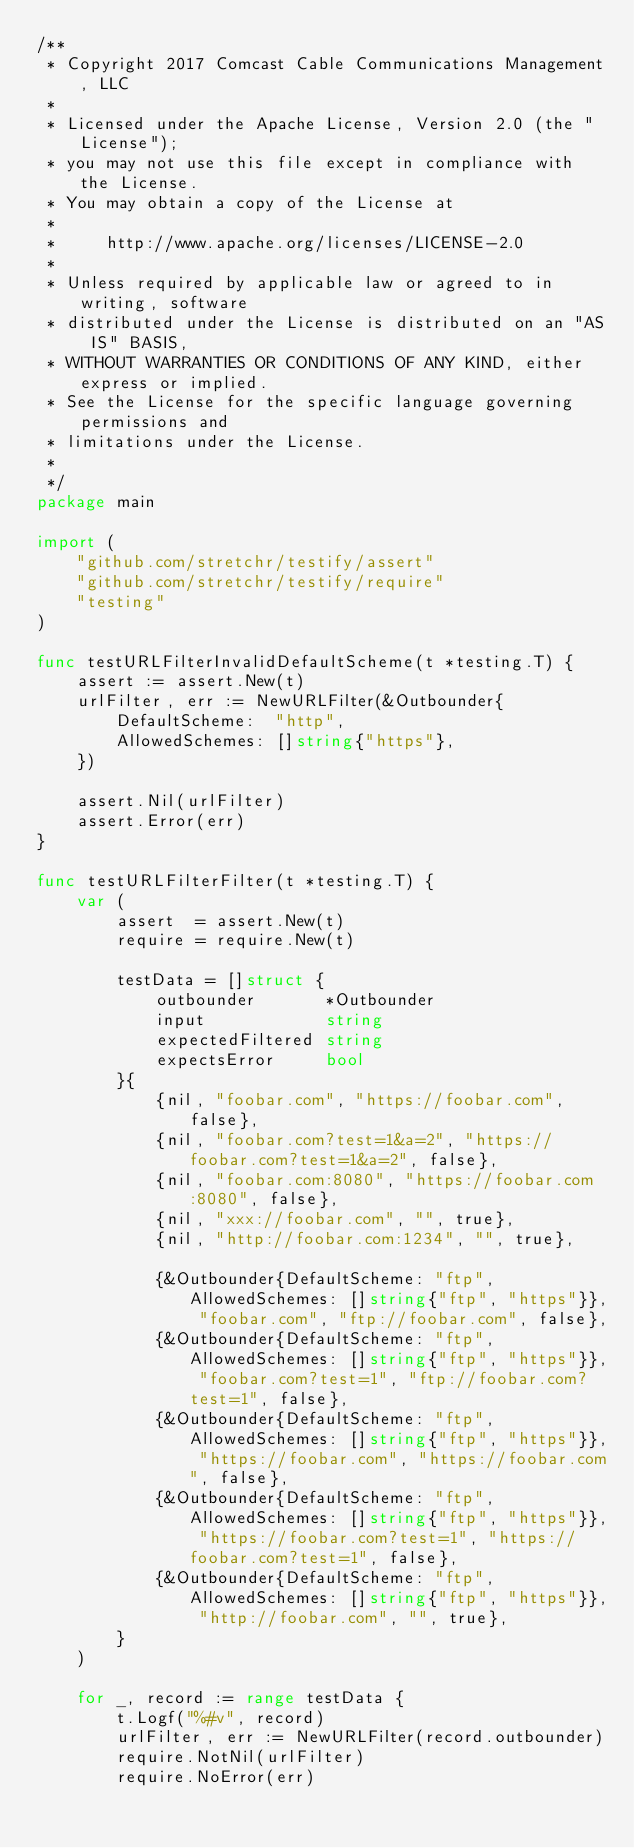<code> <loc_0><loc_0><loc_500><loc_500><_Go_>/**
 * Copyright 2017 Comcast Cable Communications Management, LLC
 *
 * Licensed under the Apache License, Version 2.0 (the "License");
 * you may not use this file except in compliance with the License.
 * You may obtain a copy of the License at
 *
 *     http://www.apache.org/licenses/LICENSE-2.0
 *
 * Unless required by applicable law or agreed to in writing, software
 * distributed under the License is distributed on an "AS IS" BASIS,
 * WITHOUT WARRANTIES OR CONDITIONS OF ANY KIND, either express or implied.
 * See the License for the specific language governing permissions and
 * limitations under the License.
 *
 */
package main

import (
	"github.com/stretchr/testify/assert"
	"github.com/stretchr/testify/require"
	"testing"
)

func testURLFilterInvalidDefaultScheme(t *testing.T) {
	assert := assert.New(t)
	urlFilter, err := NewURLFilter(&Outbounder{
		DefaultScheme:  "http",
		AllowedSchemes: []string{"https"},
	})

	assert.Nil(urlFilter)
	assert.Error(err)
}

func testURLFilterFilter(t *testing.T) {
	var (
		assert  = assert.New(t)
		require = require.New(t)

		testData = []struct {
			outbounder       *Outbounder
			input            string
			expectedFiltered string
			expectsError     bool
		}{
			{nil, "foobar.com", "https://foobar.com", false},
			{nil, "foobar.com?test=1&a=2", "https://foobar.com?test=1&a=2", false},
			{nil, "foobar.com:8080", "https://foobar.com:8080", false},
			{nil, "xxx://foobar.com", "", true},
			{nil, "http://foobar.com:1234", "", true},

			{&Outbounder{DefaultScheme: "ftp", AllowedSchemes: []string{"ftp", "https"}}, "foobar.com", "ftp://foobar.com", false},
			{&Outbounder{DefaultScheme: "ftp", AllowedSchemes: []string{"ftp", "https"}}, "foobar.com?test=1", "ftp://foobar.com?test=1", false},
			{&Outbounder{DefaultScheme: "ftp", AllowedSchemes: []string{"ftp", "https"}}, "https://foobar.com", "https://foobar.com", false},
			{&Outbounder{DefaultScheme: "ftp", AllowedSchemes: []string{"ftp", "https"}}, "https://foobar.com?test=1", "https://foobar.com?test=1", false},
			{&Outbounder{DefaultScheme: "ftp", AllowedSchemes: []string{"ftp", "https"}}, "http://foobar.com", "", true},
		}
	)

	for _, record := range testData {
		t.Logf("%#v", record)
		urlFilter, err := NewURLFilter(record.outbounder)
		require.NotNil(urlFilter)
		require.NoError(err)
</code> 